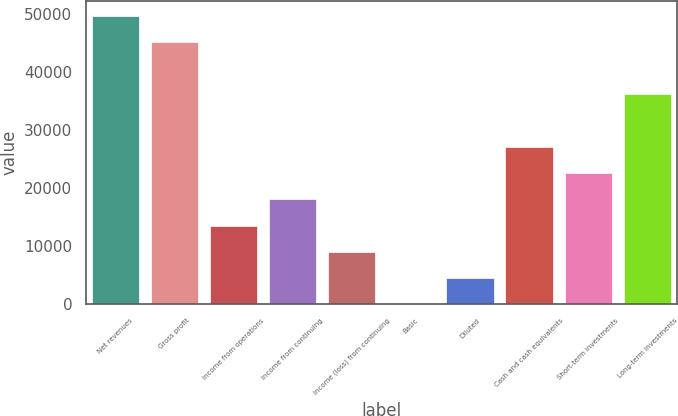Convert chart. <chart><loc_0><loc_0><loc_500><loc_500><bar_chart><fcel>Net revenues<fcel>Gross profit<fcel>Income from operations<fcel>Income from continuing<fcel>Income (loss) from continuing<fcel>Basic<fcel>Diluted<fcel>Cash and cash equivalents<fcel>Short-term investments<fcel>Long-term investments<nl><fcel>49645.1<fcel>45132<fcel>13540.1<fcel>18053.2<fcel>9026.95<fcel>0.69<fcel>4513.82<fcel>27079.5<fcel>22566.3<fcel>36105.7<nl></chart> 